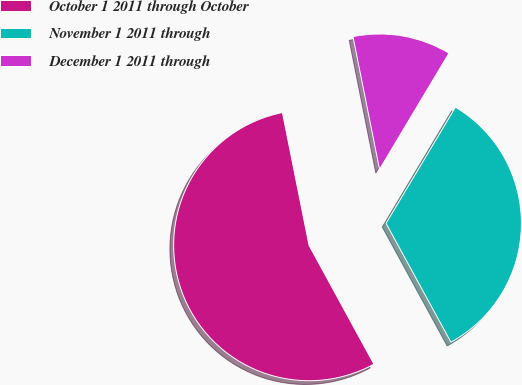<chart> <loc_0><loc_0><loc_500><loc_500><pie_chart><fcel>October 1 2011 through October<fcel>November 1 2011 through<fcel>December 1 2011 through<nl><fcel>54.81%<fcel>33.47%<fcel>11.72%<nl></chart> 